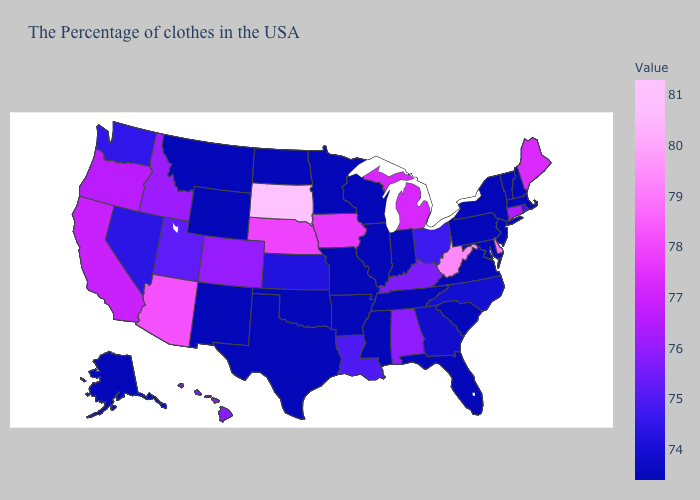Among the states that border Oklahoma , which have the highest value?
Answer briefly. Colorado. Which states hav the highest value in the Northeast?
Quick response, please. Maine. Which states have the lowest value in the West?
Write a very short answer. Wyoming, New Mexico, Montana, Alaska. Which states have the lowest value in the USA?
Answer briefly. Massachusetts, New Hampshire, Vermont, New York, New Jersey, Maryland, Pennsylvania, Virginia, South Carolina, Florida, Indiana, Tennessee, Wisconsin, Illinois, Mississippi, Missouri, Arkansas, Minnesota, Oklahoma, Texas, North Dakota, Wyoming, New Mexico, Montana, Alaska. Among the states that border Connecticut , does New York have the highest value?
Short answer required. No. 